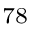Convert formula to latex. <formula><loc_0><loc_0><loc_500><loc_500>^ { 7 8 }</formula> 